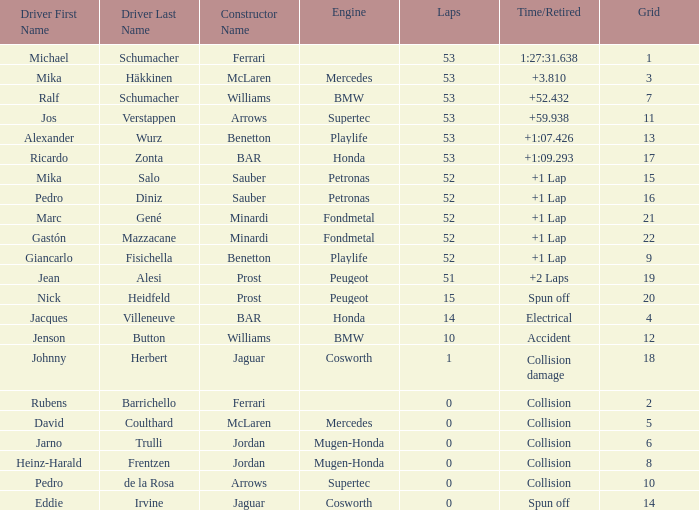What is the average Laps for a grid smaller than 17, and a Constructor of williams - bmw, driven by jenson button? 10.0. 